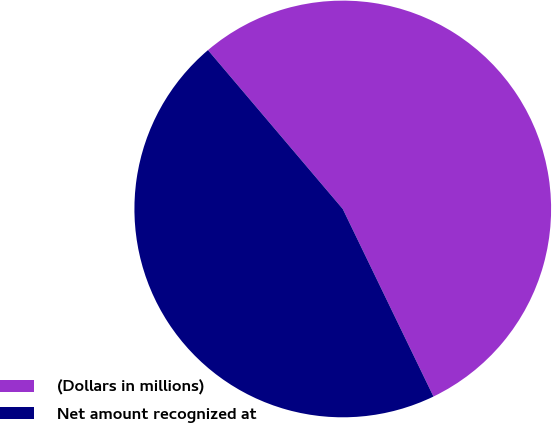<chart> <loc_0><loc_0><loc_500><loc_500><pie_chart><fcel>(Dollars in millions)<fcel>Net amount recognized at<nl><fcel>54.03%<fcel>45.97%<nl></chart> 